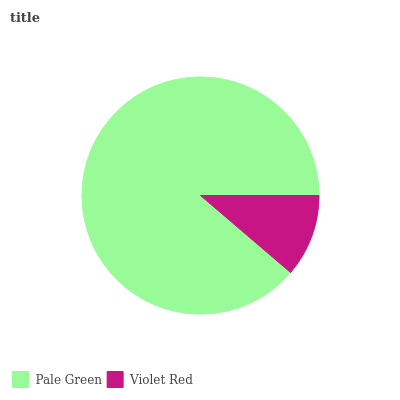Is Violet Red the minimum?
Answer yes or no. Yes. Is Pale Green the maximum?
Answer yes or no. Yes. Is Violet Red the maximum?
Answer yes or no. No. Is Pale Green greater than Violet Red?
Answer yes or no. Yes. Is Violet Red less than Pale Green?
Answer yes or no. Yes. Is Violet Red greater than Pale Green?
Answer yes or no. No. Is Pale Green less than Violet Red?
Answer yes or no. No. Is Pale Green the high median?
Answer yes or no. Yes. Is Violet Red the low median?
Answer yes or no. Yes. Is Violet Red the high median?
Answer yes or no. No. Is Pale Green the low median?
Answer yes or no. No. 